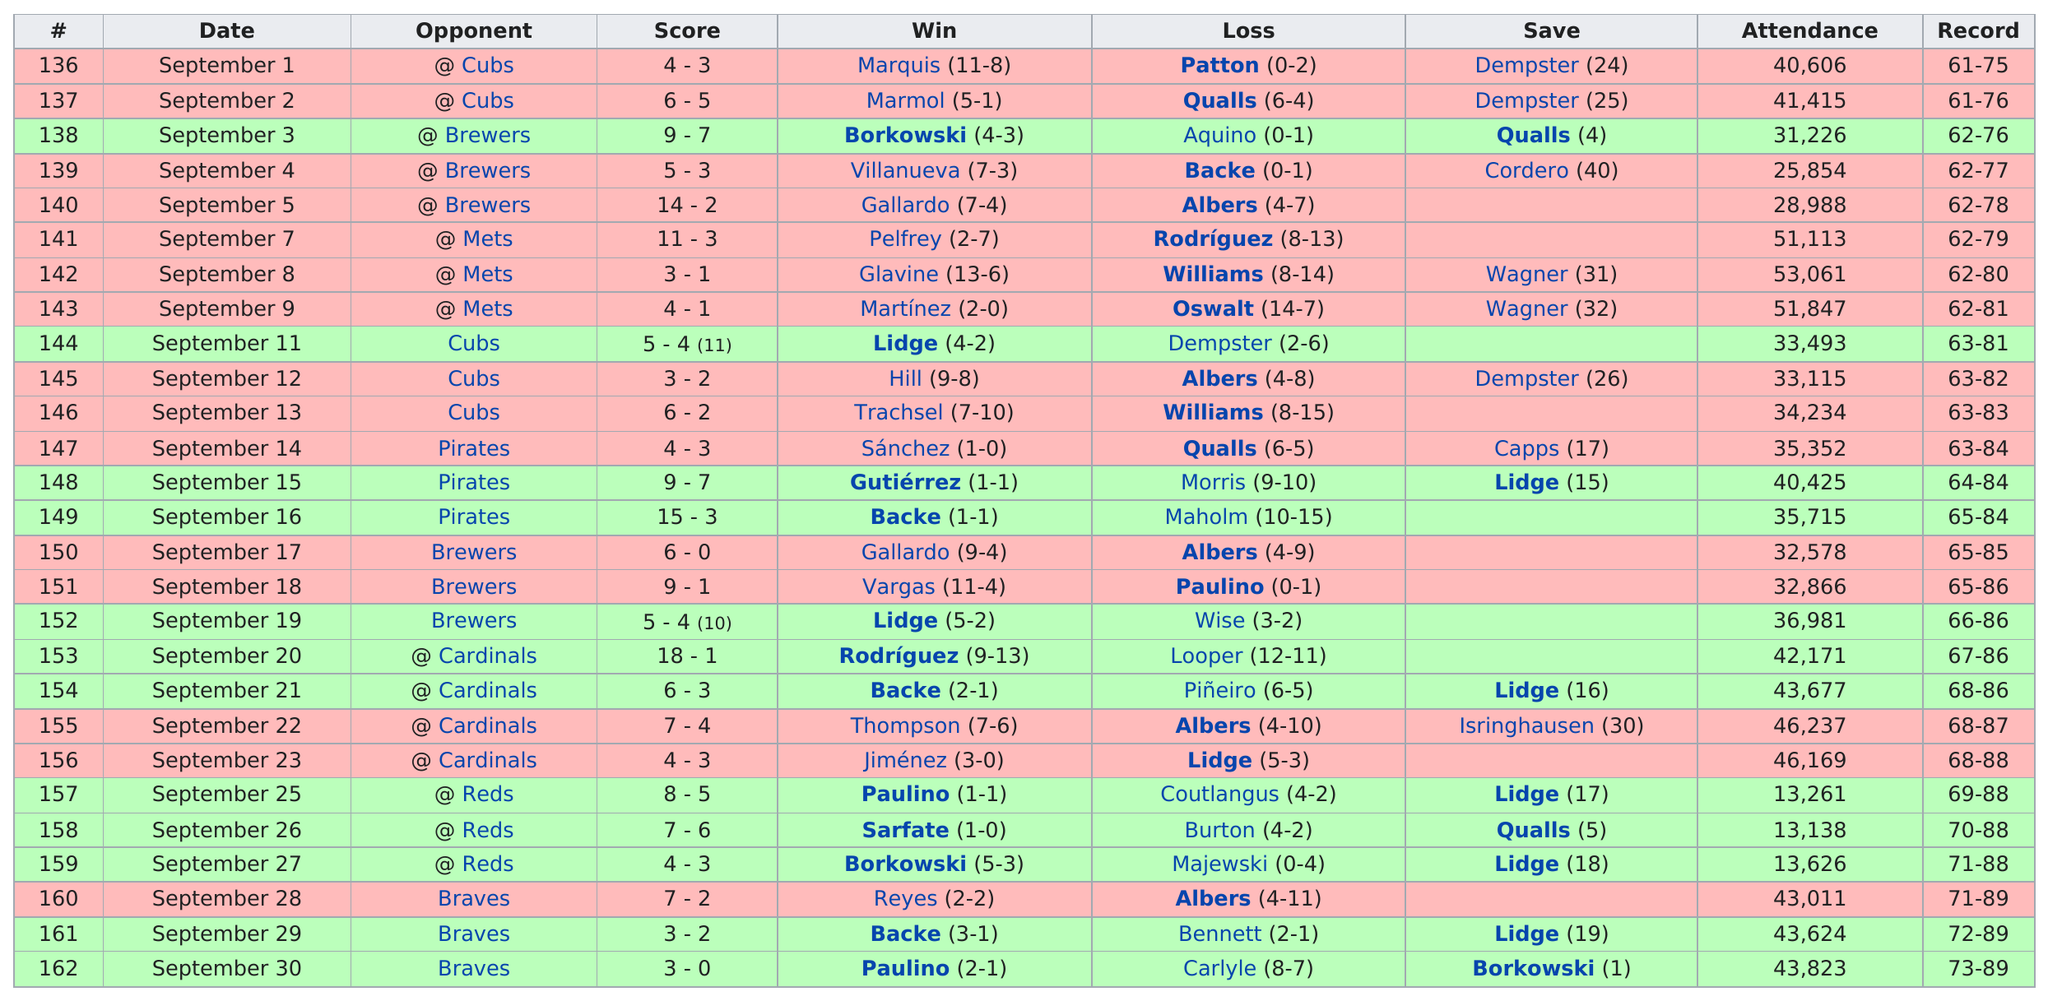Indicate a few pertinent items in this graphic. Which games had an attendance of below 14,000? Games 157, 158, and 159 had attendance below this threshold. The Texas Rangers were the next opponent for the Houston Astros after they played against the St. Louis Cardinals. In September 2007, the Astros pitcher Brad Lidge accumulated fewer than seven saves, compared to the previous months. The total number of dates is 27. Out of the five games that the Houston Astros played against the Chicago Cubs in September 2007, the Astros won 1. 